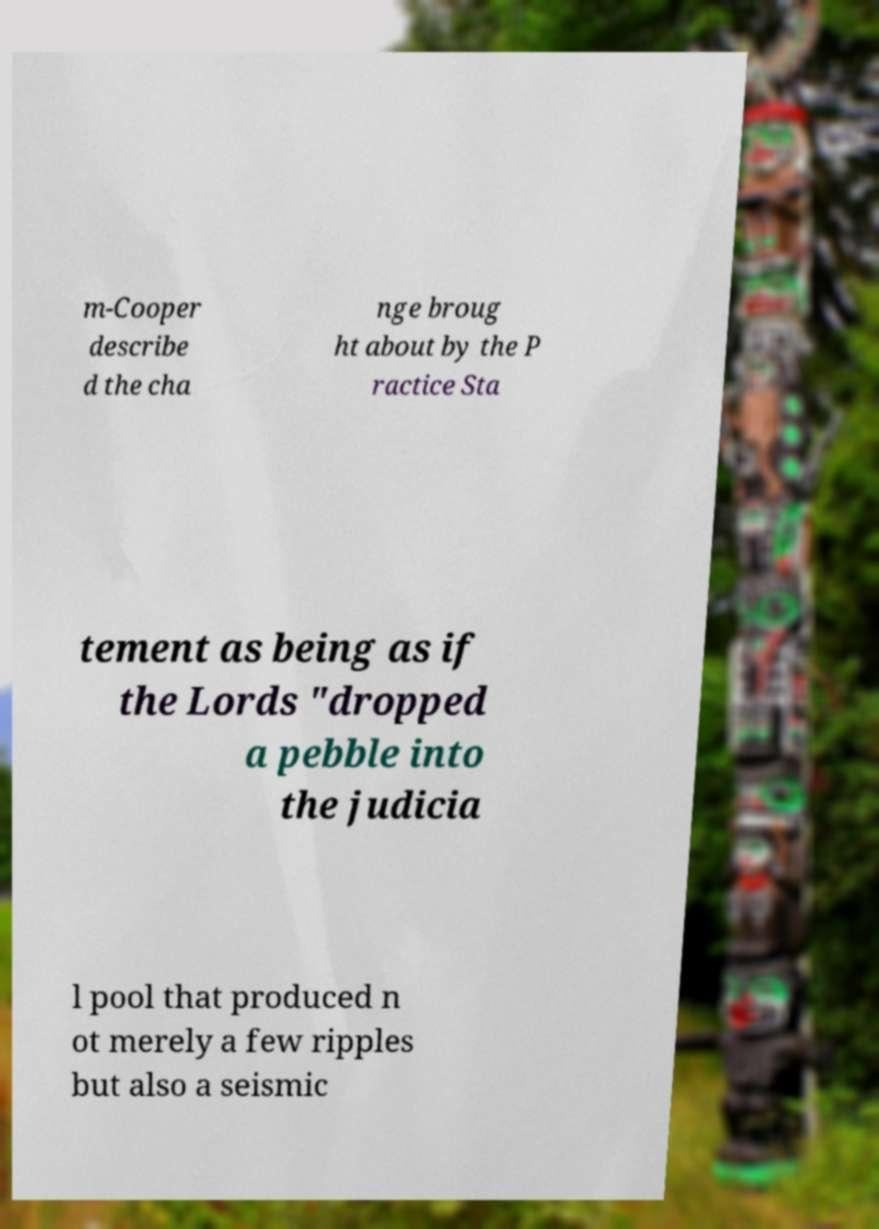There's text embedded in this image that I need extracted. Can you transcribe it verbatim? m-Cooper describe d the cha nge broug ht about by the P ractice Sta tement as being as if the Lords "dropped a pebble into the judicia l pool that produced n ot merely a few ripples but also a seismic 